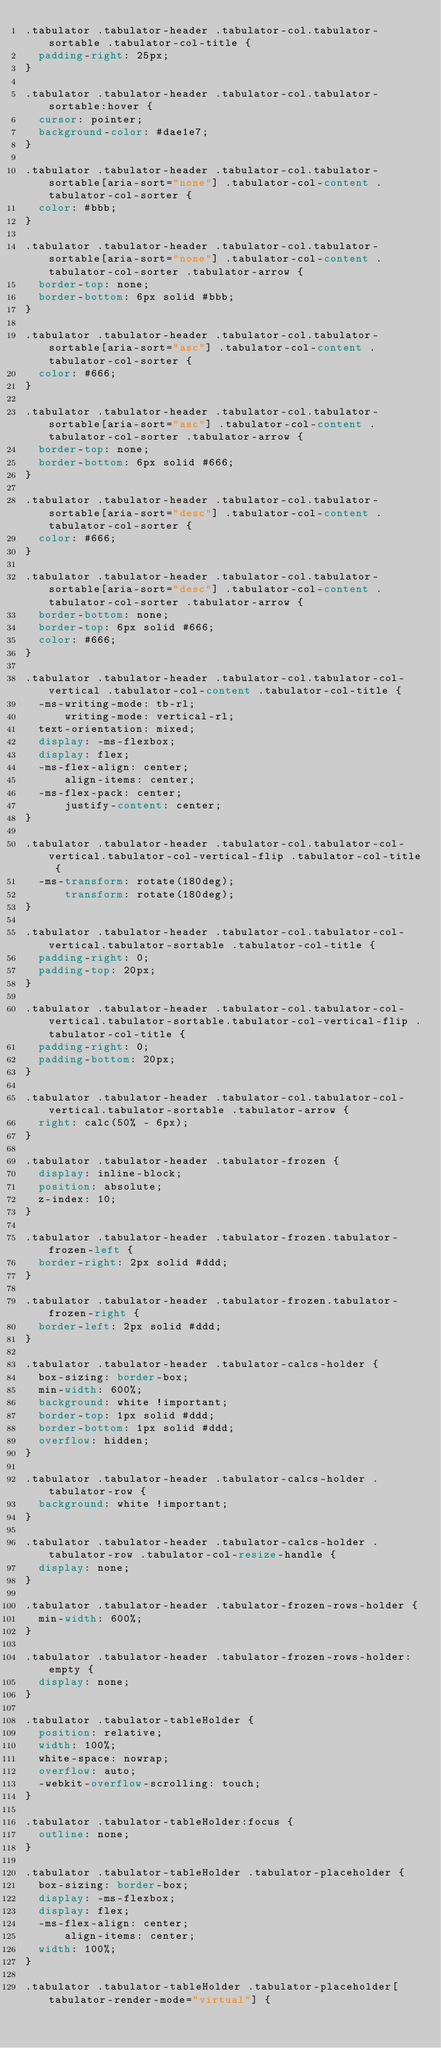<code> <loc_0><loc_0><loc_500><loc_500><_CSS_>.tabulator .tabulator-header .tabulator-col.tabulator-sortable .tabulator-col-title {
  padding-right: 25px;
}

.tabulator .tabulator-header .tabulator-col.tabulator-sortable:hover {
  cursor: pointer;
  background-color: #dae1e7;
}

.tabulator .tabulator-header .tabulator-col.tabulator-sortable[aria-sort="none"] .tabulator-col-content .tabulator-col-sorter {
  color: #bbb;
}

.tabulator .tabulator-header .tabulator-col.tabulator-sortable[aria-sort="none"] .tabulator-col-content .tabulator-col-sorter .tabulator-arrow {
  border-top: none;
  border-bottom: 6px solid #bbb;
}

.tabulator .tabulator-header .tabulator-col.tabulator-sortable[aria-sort="asc"] .tabulator-col-content .tabulator-col-sorter {
  color: #666;
}

.tabulator .tabulator-header .tabulator-col.tabulator-sortable[aria-sort="asc"] .tabulator-col-content .tabulator-col-sorter .tabulator-arrow {
  border-top: none;
  border-bottom: 6px solid #666;
}

.tabulator .tabulator-header .tabulator-col.tabulator-sortable[aria-sort="desc"] .tabulator-col-content .tabulator-col-sorter {
  color: #666;
}

.tabulator .tabulator-header .tabulator-col.tabulator-sortable[aria-sort="desc"] .tabulator-col-content .tabulator-col-sorter .tabulator-arrow {
  border-bottom: none;
  border-top: 6px solid #666;
  color: #666;
}

.tabulator .tabulator-header .tabulator-col.tabulator-col-vertical .tabulator-col-content .tabulator-col-title {
  -ms-writing-mode: tb-rl;
      writing-mode: vertical-rl;
  text-orientation: mixed;
  display: -ms-flexbox;
  display: flex;
  -ms-flex-align: center;
      align-items: center;
  -ms-flex-pack: center;
      justify-content: center;
}

.tabulator .tabulator-header .tabulator-col.tabulator-col-vertical.tabulator-col-vertical-flip .tabulator-col-title {
  -ms-transform: rotate(180deg);
      transform: rotate(180deg);
}

.tabulator .tabulator-header .tabulator-col.tabulator-col-vertical.tabulator-sortable .tabulator-col-title {
  padding-right: 0;
  padding-top: 20px;
}

.tabulator .tabulator-header .tabulator-col.tabulator-col-vertical.tabulator-sortable.tabulator-col-vertical-flip .tabulator-col-title {
  padding-right: 0;
  padding-bottom: 20px;
}

.tabulator .tabulator-header .tabulator-col.tabulator-col-vertical.tabulator-sortable .tabulator-arrow {
  right: calc(50% - 6px);
}

.tabulator .tabulator-header .tabulator-frozen {
  display: inline-block;
  position: absolute;
  z-index: 10;
}

.tabulator .tabulator-header .tabulator-frozen.tabulator-frozen-left {
  border-right: 2px solid #ddd;
}

.tabulator .tabulator-header .tabulator-frozen.tabulator-frozen-right {
  border-left: 2px solid #ddd;
}

.tabulator .tabulator-header .tabulator-calcs-holder {
  box-sizing: border-box;
  min-width: 600%;
  background: white !important;
  border-top: 1px solid #ddd;
  border-bottom: 1px solid #ddd;
  overflow: hidden;
}

.tabulator .tabulator-header .tabulator-calcs-holder .tabulator-row {
  background: white !important;
}

.tabulator .tabulator-header .tabulator-calcs-holder .tabulator-row .tabulator-col-resize-handle {
  display: none;
}

.tabulator .tabulator-header .tabulator-frozen-rows-holder {
  min-width: 600%;
}

.tabulator .tabulator-header .tabulator-frozen-rows-holder:empty {
  display: none;
}

.tabulator .tabulator-tableHolder {
  position: relative;
  width: 100%;
  white-space: nowrap;
  overflow: auto;
  -webkit-overflow-scrolling: touch;
}

.tabulator .tabulator-tableHolder:focus {
  outline: none;
}

.tabulator .tabulator-tableHolder .tabulator-placeholder {
  box-sizing: border-box;
  display: -ms-flexbox;
  display: flex;
  -ms-flex-align: center;
      align-items: center;
  width: 100%;
}

.tabulator .tabulator-tableHolder .tabulator-placeholder[tabulator-render-mode="virtual"] {</code> 